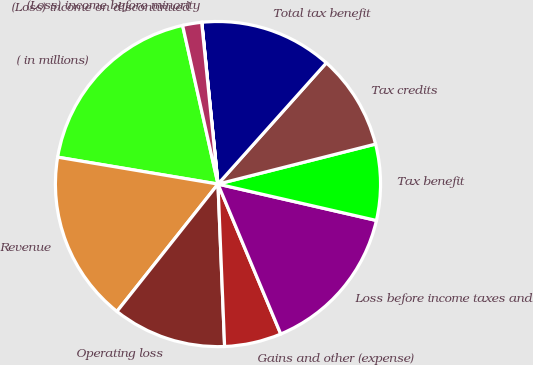Convert chart to OTSL. <chart><loc_0><loc_0><loc_500><loc_500><pie_chart><fcel>( in millions)<fcel>Revenue<fcel>Operating loss<fcel>Gains and other (expense)<fcel>Loss before income taxes and<fcel>Tax benefit<fcel>Tax credits<fcel>Total tax benefit<fcel>(Loss) income before minority<fcel>(Loss) income on discontinued<nl><fcel>18.86%<fcel>16.97%<fcel>11.32%<fcel>5.66%<fcel>15.09%<fcel>7.55%<fcel>9.43%<fcel>13.2%<fcel>0.01%<fcel>1.89%<nl></chart> 